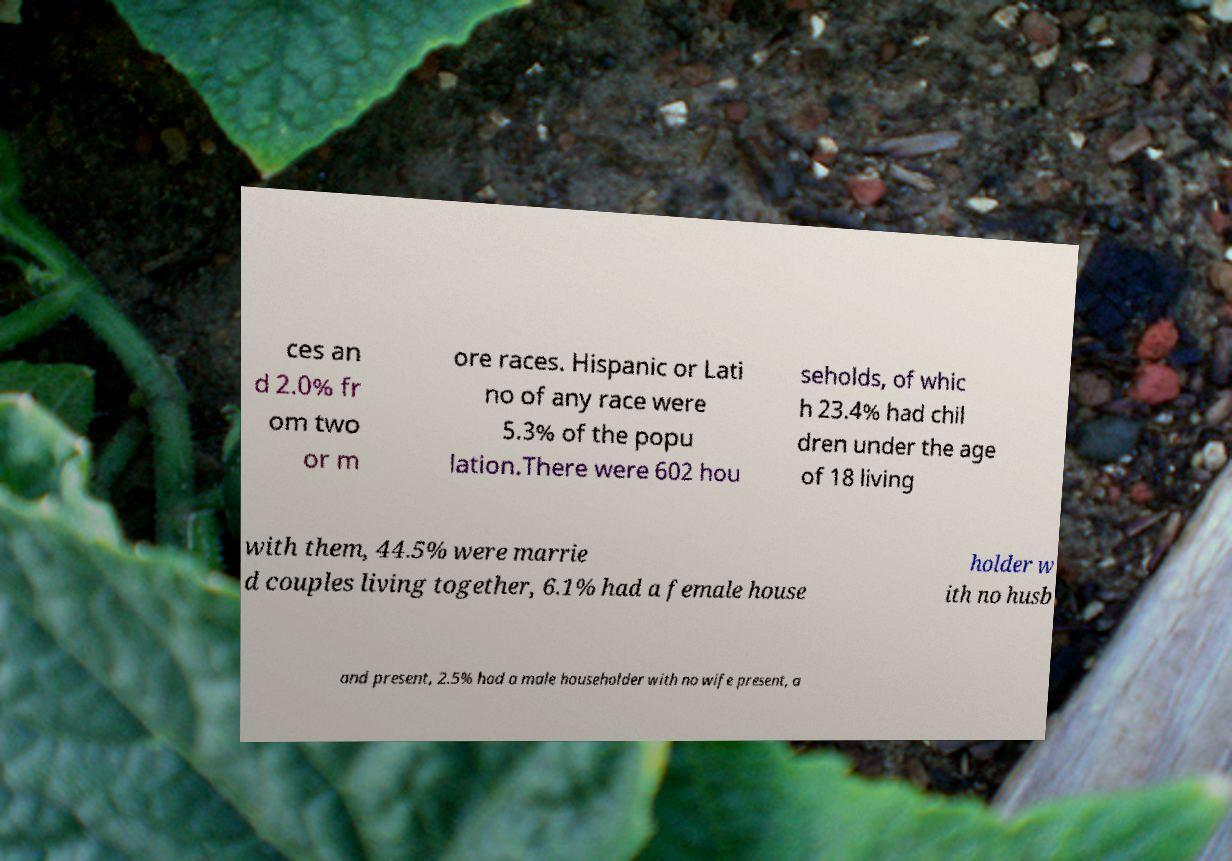Could you assist in decoding the text presented in this image and type it out clearly? ces an d 2.0% fr om two or m ore races. Hispanic or Lati no of any race were 5.3% of the popu lation.There were 602 hou seholds, of whic h 23.4% had chil dren under the age of 18 living with them, 44.5% were marrie d couples living together, 6.1% had a female house holder w ith no husb and present, 2.5% had a male householder with no wife present, a 